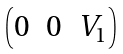<formula> <loc_0><loc_0><loc_500><loc_500>\begin{pmatrix} 0 & 0 & V _ { 1 } \end{pmatrix}</formula> 